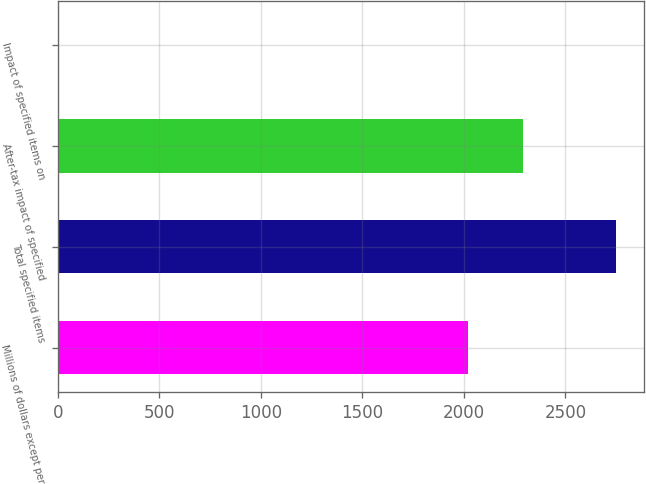Convert chart. <chart><loc_0><loc_0><loc_500><loc_500><bar_chart><fcel>Millions of dollars except per<fcel>Total specified items<fcel>After-tax impact of specified<fcel>Impact of specified items on<nl><fcel>2019<fcel>2749<fcel>2293.13<fcel>7.74<nl></chart> 